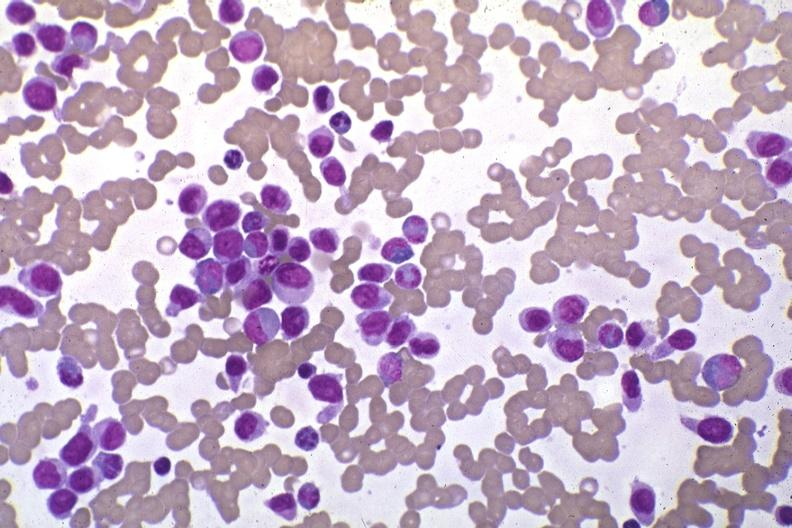do wrights stain pleomorphic leukemic cells in peripheral blood prior to therapy?
Answer the question using a single word or phrase. Yes 